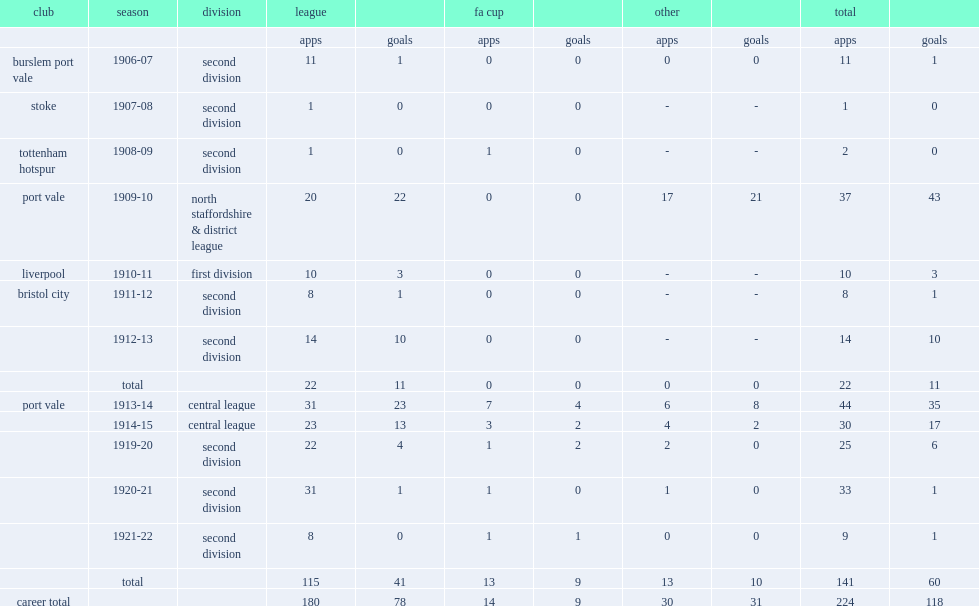In the 1910-11 season, which division did joe brough play for liverpool? First division. 